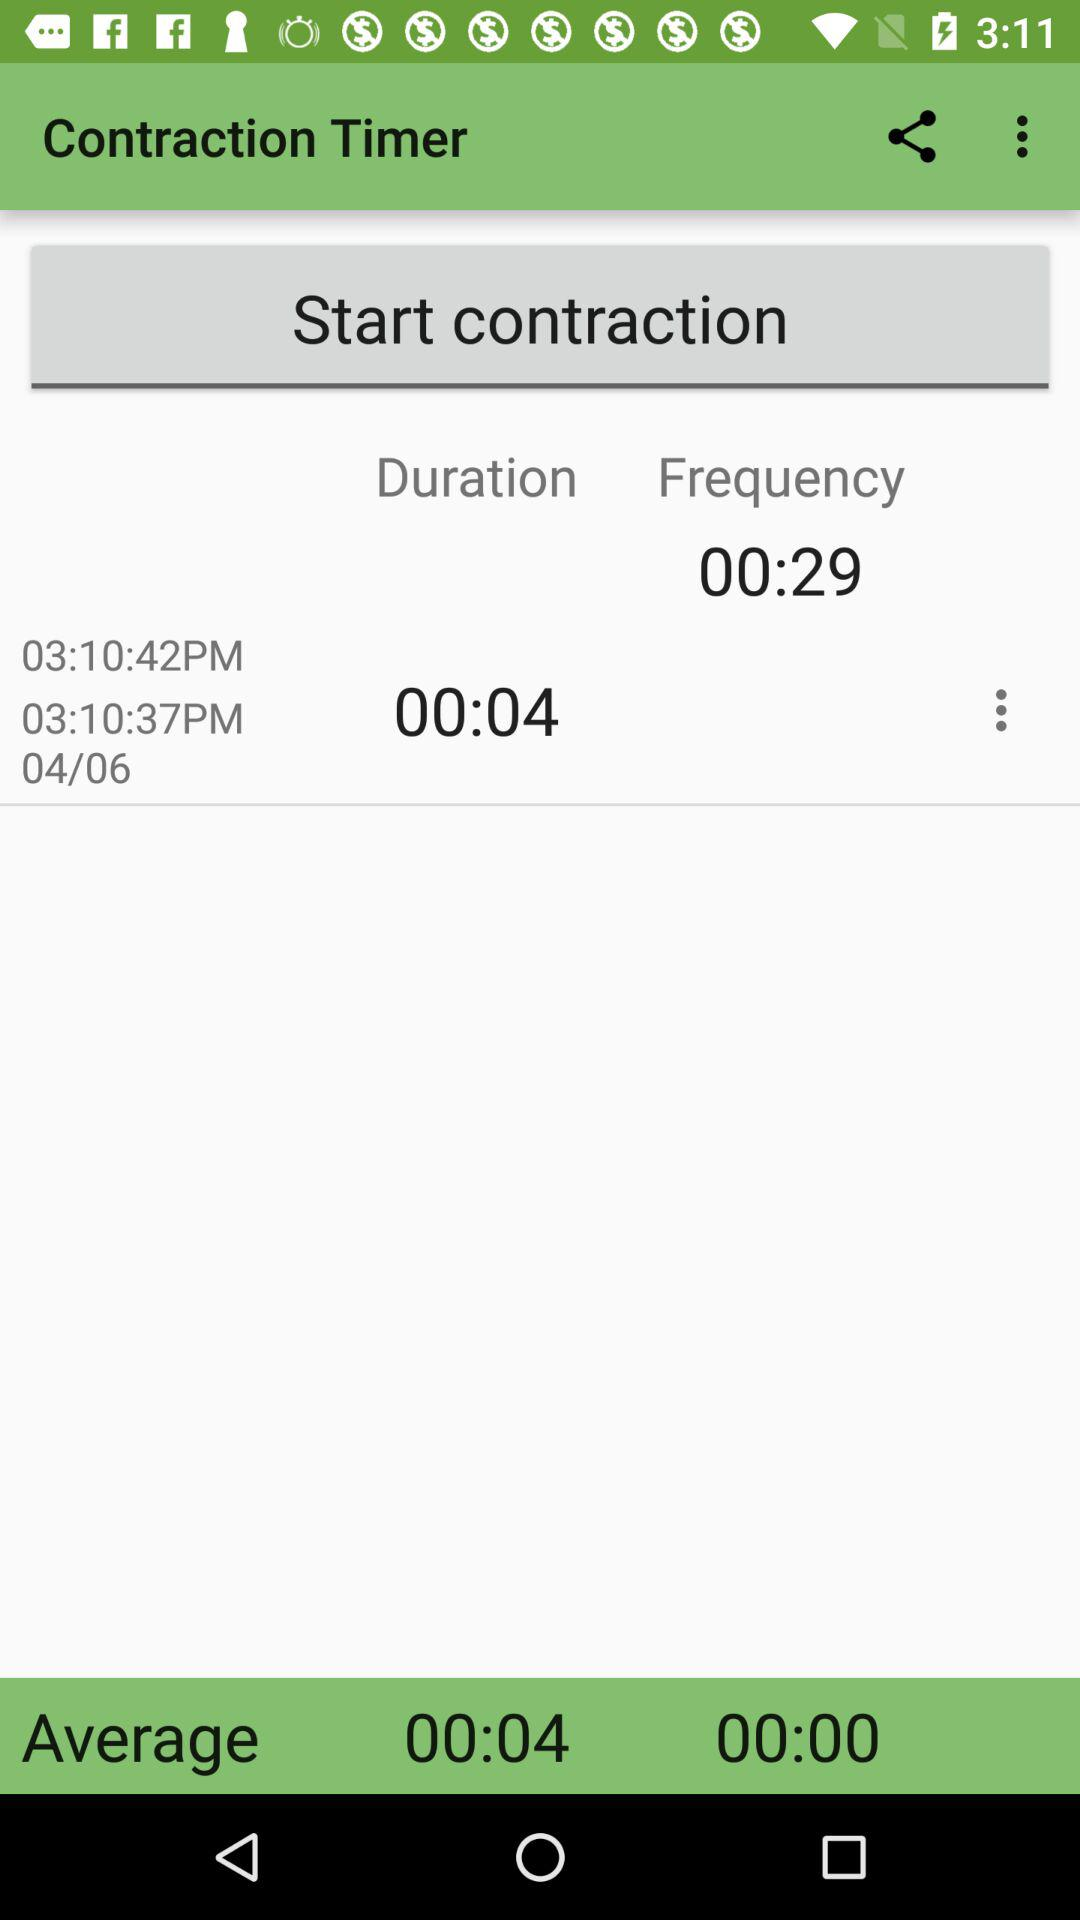What is the average duration? The average duration is 4 seconds. 